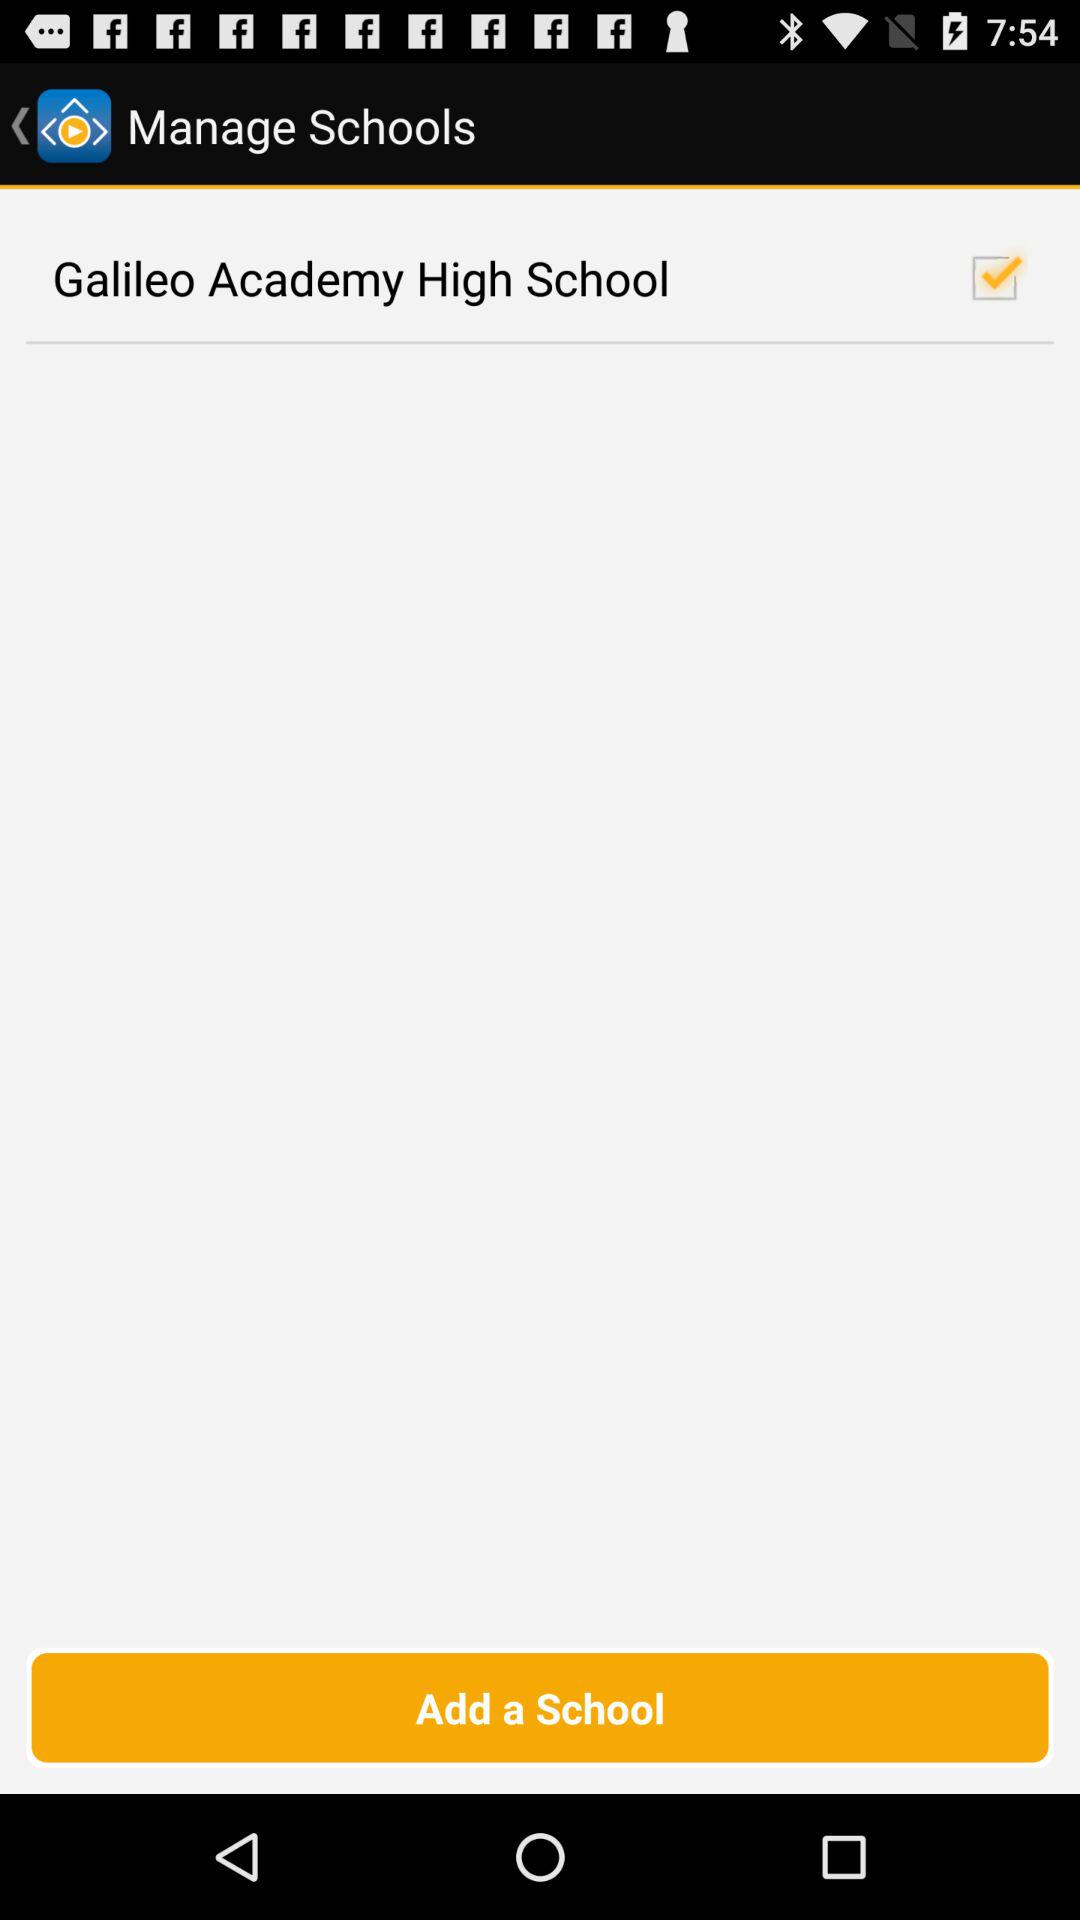What school has been checked? The checked school is "Galileo Academy High School". 